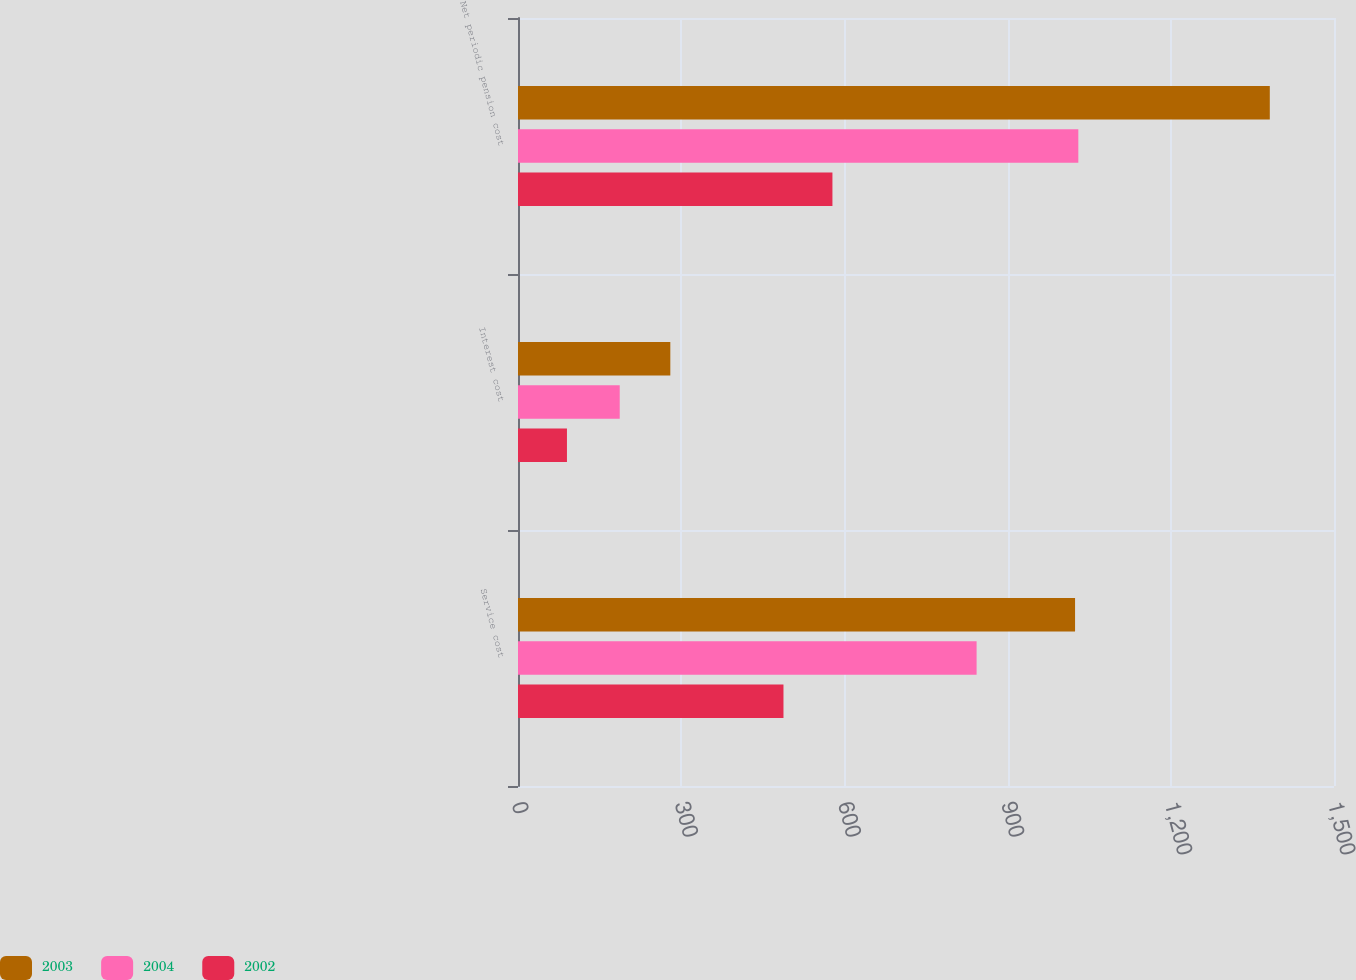<chart> <loc_0><loc_0><loc_500><loc_500><stacked_bar_chart><ecel><fcel>Service cost<fcel>Interest cost<fcel>Net periodic pension cost<nl><fcel>2003<fcel>1024<fcel>280<fcel>1382<nl><fcel>2004<fcel>843<fcel>187<fcel>1030<nl><fcel>2002<fcel>488<fcel>90<fcel>578<nl></chart> 